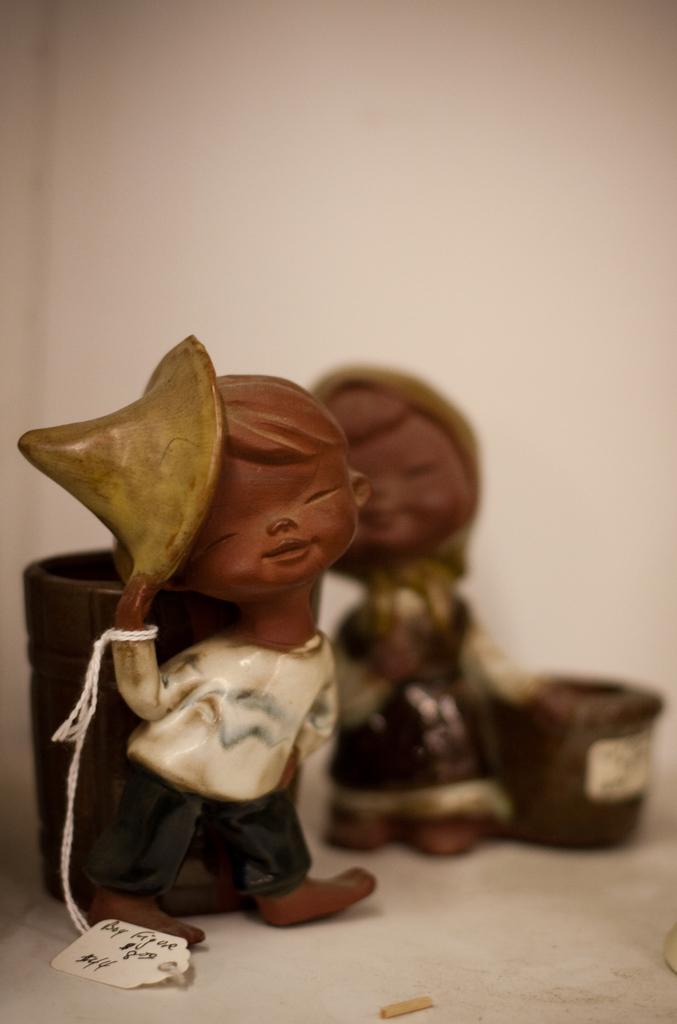Describe this image in one or two sentences. In the image there is a doll and there is another doll behind that but it is blurred. 